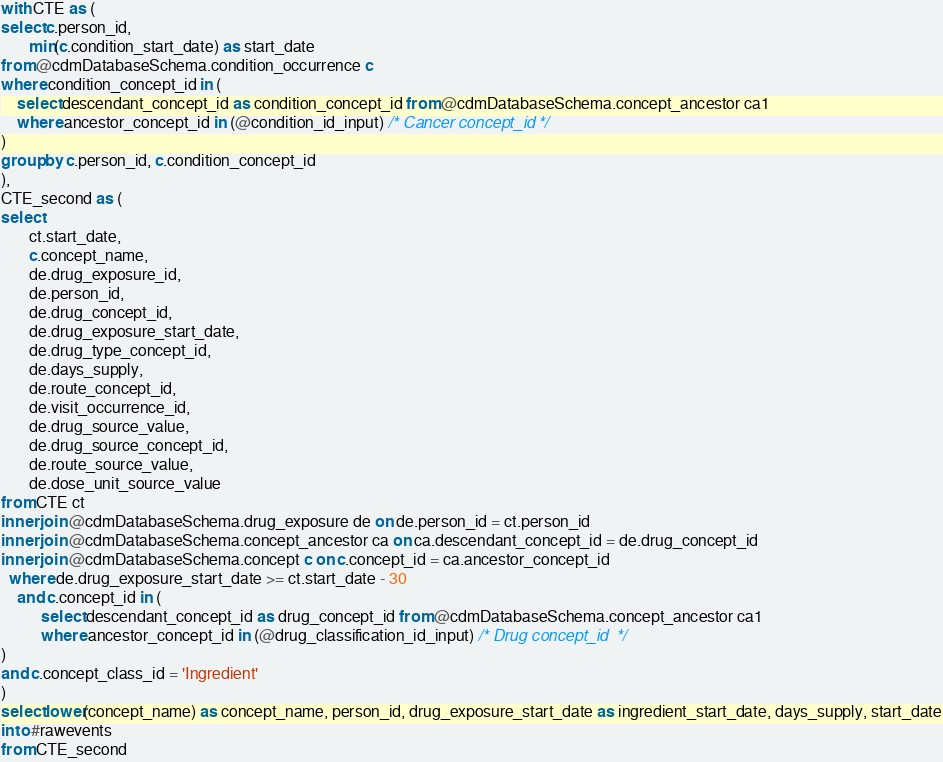<code> <loc_0><loc_0><loc_500><loc_500><_SQL_>with CTE as (
select c.person_id,
	   min(c.condition_start_date) as start_date
from @cdmDatabaseSchema.condition_occurrence c
where condition_concept_id in (
	select descendant_concept_id as condition_concept_id from @cdmDatabaseSchema.concept_ancestor ca1
	where ancestor_concept_id in (@condition_id_input) /* Cancer concept_id */ 
)
group by c.person_id, c.condition_concept_id
),
CTE_second as (
select 
	   ct.start_date,
	   c.concept_name,
	   de.drug_exposure_id, 
	   de.person_id, 
	   de.drug_concept_id, 
	   de.drug_exposure_start_date, 
	   de.drug_type_concept_id, 
	   de.days_supply, 
	   de.route_concept_id, 
	   de.visit_occurrence_id, 
	   de.drug_source_value, 
	   de.drug_source_concept_id, 
	   de.route_source_value, 
	   de.dose_unit_source_value
from CTE ct
inner join @cdmDatabaseSchema.drug_exposure de on de.person_id = ct.person_id
inner join @cdmDatabaseSchema.concept_ancestor ca on ca.descendant_concept_id = de.drug_concept_id
inner join @cdmDatabaseSchema.concept c on c.concept_id = ca.ancestor_concept_id
  where de.drug_exposure_start_date >= ct.start_date - 30
	and c.concept_id in (
		  select descendant_concept_id as drug_concept_id from @cdmDatabaseSchema.concept_ancestor ca1
		  where ancestor_concept_id in (@drug_classification_id_input) /* Drug concept_id  */ 
)
and c.concept_class_id = 'Ingredient'
)
select lower(concept_name) as concept_name, person_id, drug_exposure_start_date as ingredient_start_date, days_supply, start_date
into #rawevents
from CTE_second
</code> 